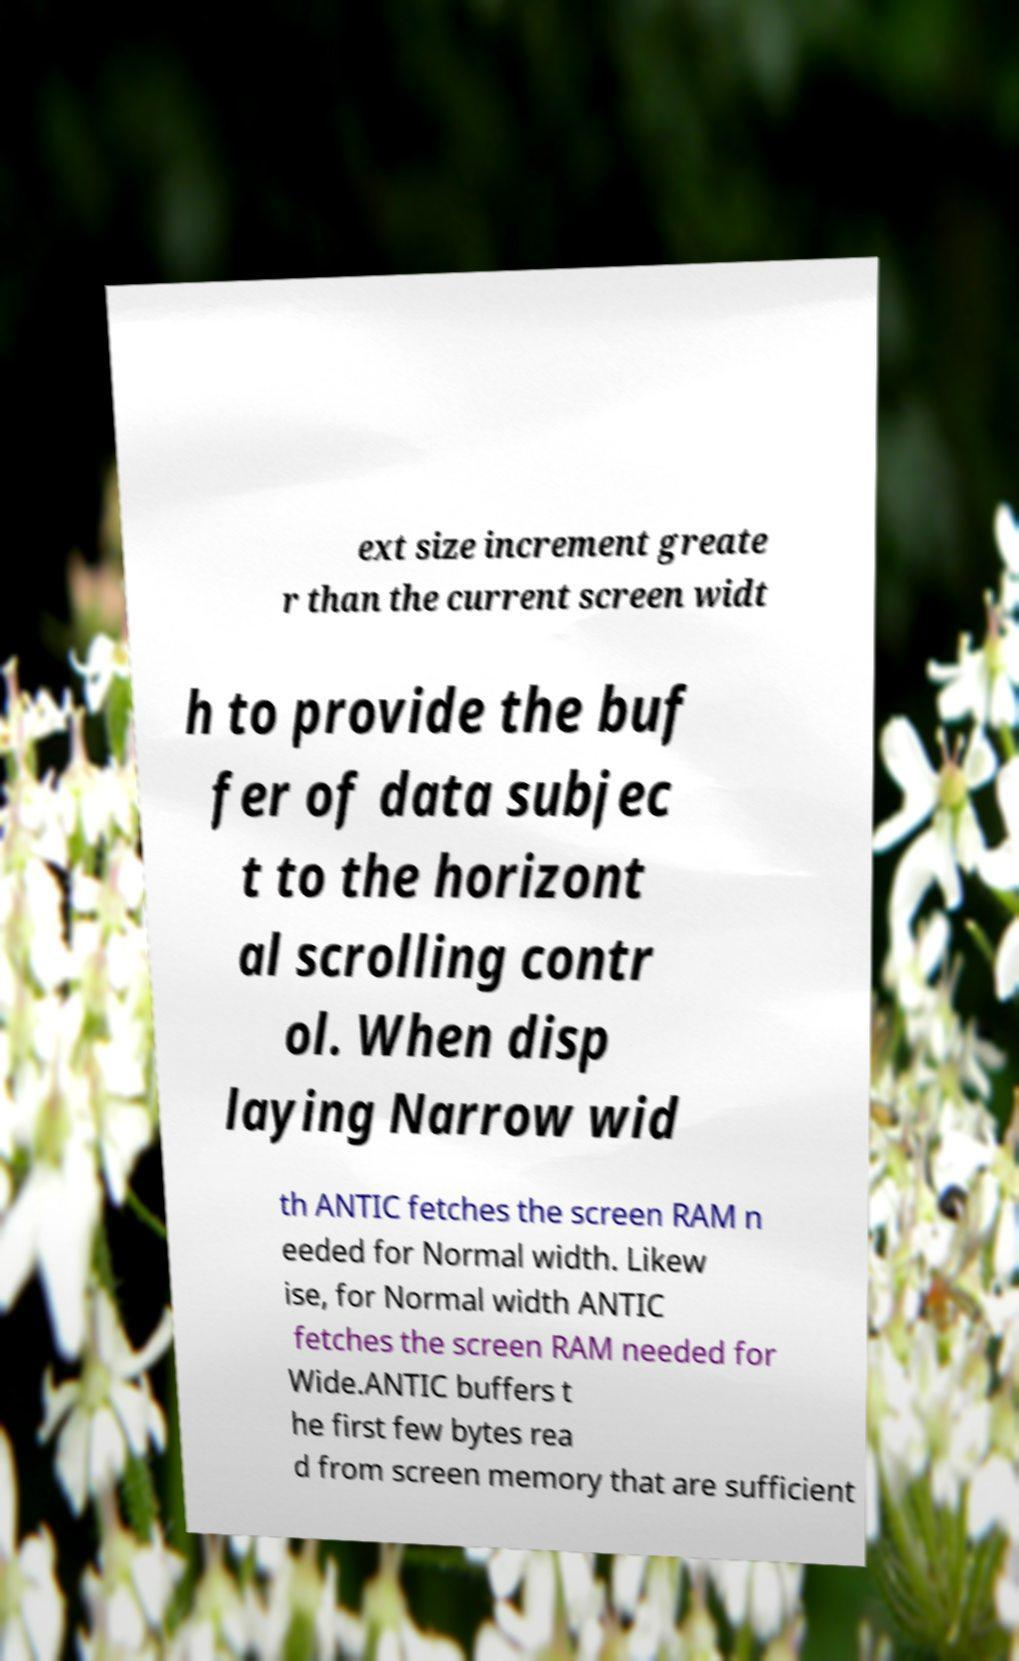For documentation purposes, I need the text within this image transcribed. Could you provide that? ext size increment greate r than the current screen widt h to provide the buf fer of data subjec t to the horizont al scrolling contr ol. When disp laying Narrow wid th ANTIC fetches the screen RAM n eeded for Normal width. Likew ise, for Normal width ANTIC fetches the screen RAM needed for Wide.ANTIC buffers t he first few bytes rea d from screen memory that are sufficient 